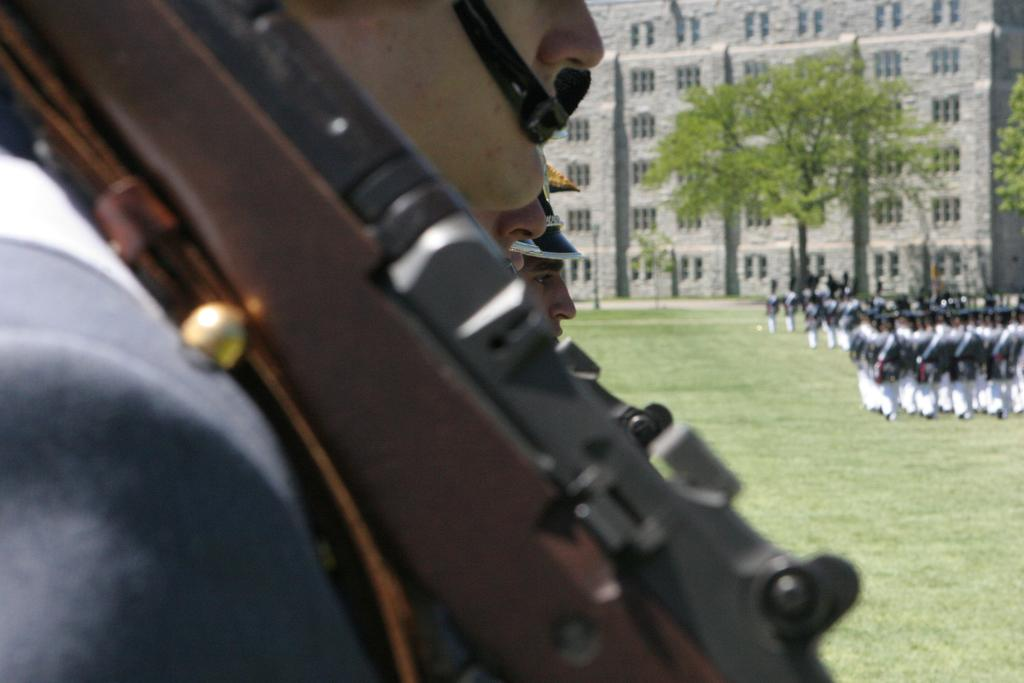What type of structure is visible in the image? There is a building in the image. What can be seen in the background of the image? There are trees in the image. What are the people in the image doing? There are people standing and walking in the image. What is the ground covered with in the image? There is grass on the ground in the image. What type of produce is being harvested by the people in the image? There is no produce or harvesting activity depicted in the image. What is the temper of the people walking in the image? The image does not provide information about the emotions or temper of the people walking. 